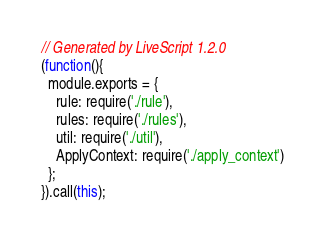Convert code to text. <code><loc_0><loc_0><loc_500><loc_500><_JavaScript_>// Generated by LiveScript 1.2.0
(function(){
  module.exports = {
    rule: require('./rule'),
    rules: require('./rules'),
    util: require('./util'),
    ApplyContext: require('./apply_context')
  };
}).call(this);
</code> 